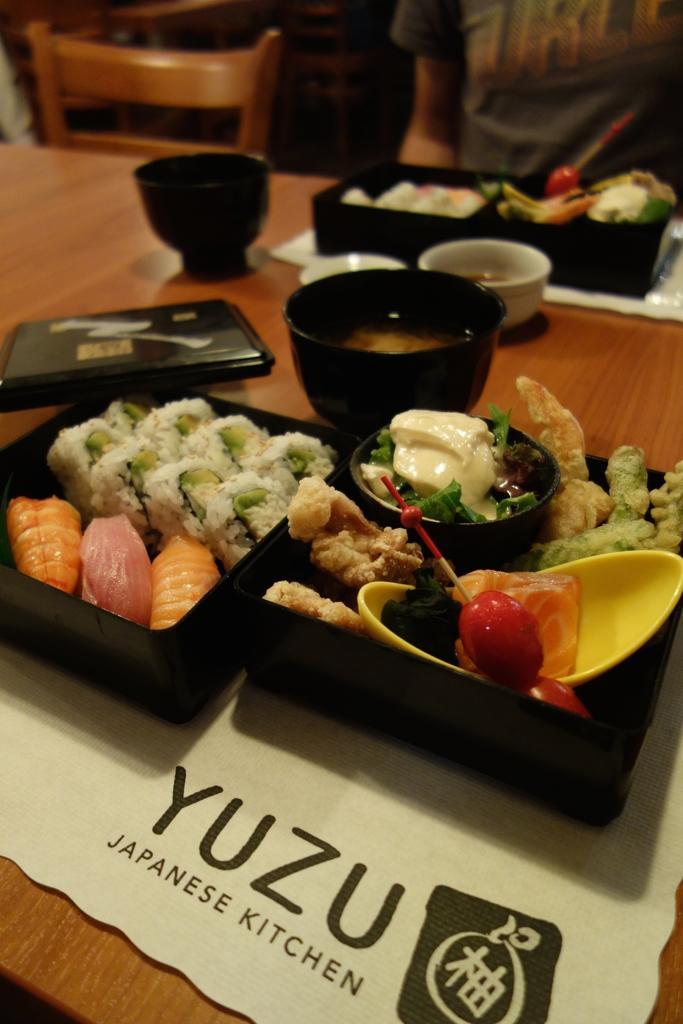Can you describe this image briefly? In this picture there is some food placed on the wooden table. Behind there is a chair and a woman wearing grey color t- shirt is sitting on the chair. In the front bottom side of the image there is a "Yuzu Japanese kitchen" written on the table mat. 